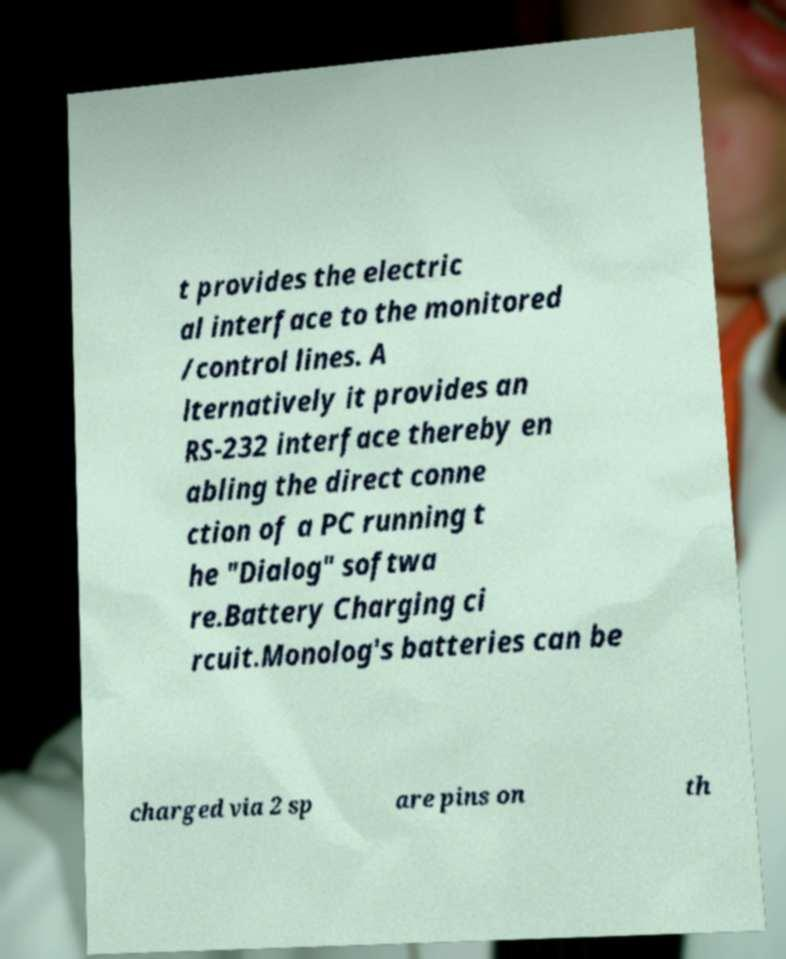Could you assist in decoding the text presented in this image and type it out clearly? t provides the electric al interface to the monitored /control lines. A lternatively it provides an RS-232 interface thereby en abling the direct conne ction of a PC running t he "Dialog" softwa re.Battery Charging ci rcuit.Monolog's batteries can be charged via 2 sp are pins on th 